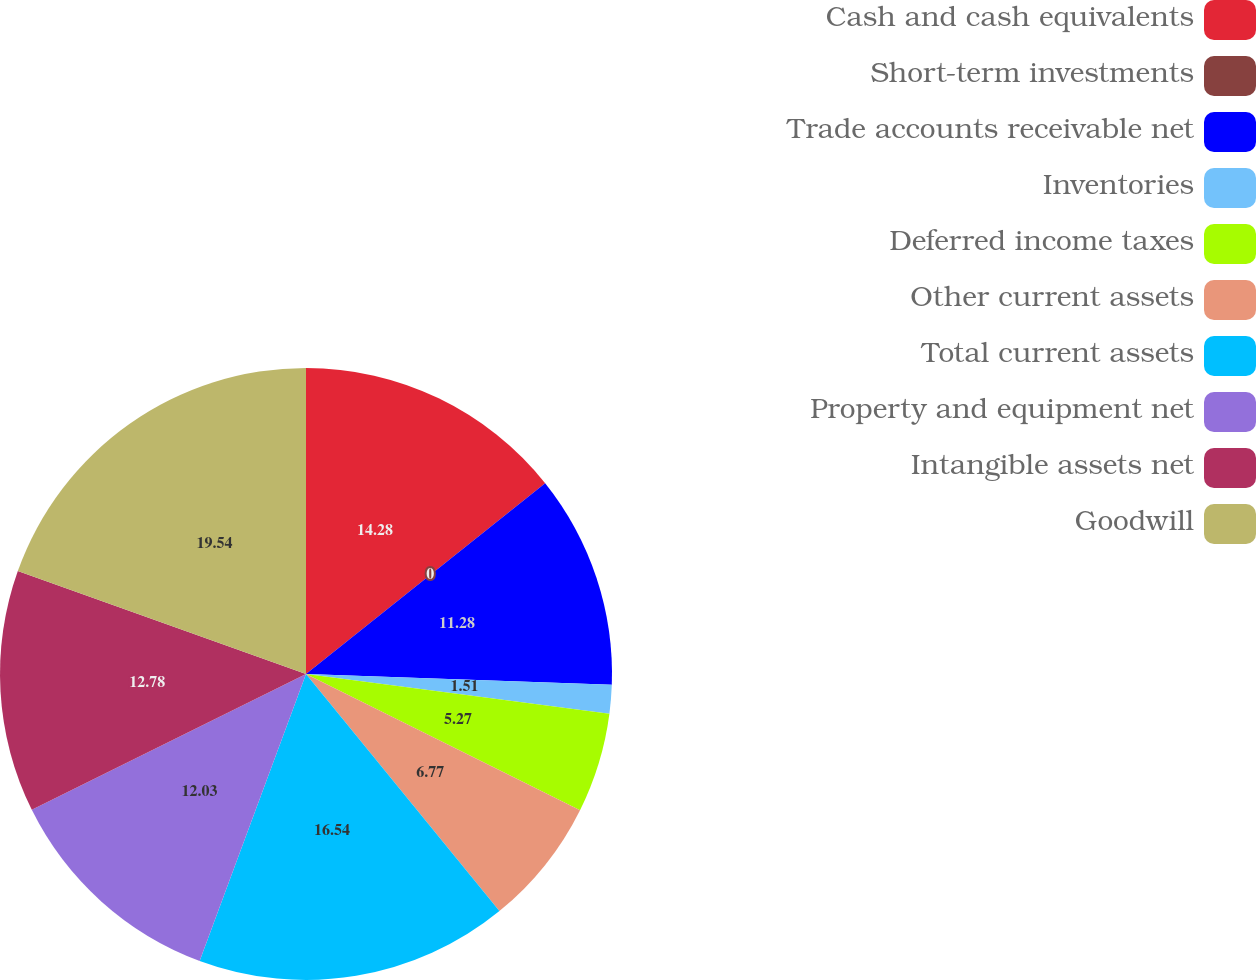Convert chart to OTSL. <chart><loc_0><loc_0><loc_500><loc_500><pie_chart><fcel>Cash and cash equivalents<fcel>Short-term investments<fcel>Trade accounts receivable net<fcel>Inventories<fcel>Deferred income taxes<fcel>Other current assets<fcel>Total current assets<fcel>Property and equipment net<fcel>Intangible assets net<fcel>Goodwill<nl><fcel>14.28%<fcel>0.0%<fcel>11.28%<fcel>1.51%<fcel>5.27%<fcel>6.77%<fcel>16.54%<fcel>12.03%<fcel>12.78%<fcel>19.54%<nl></chart> 